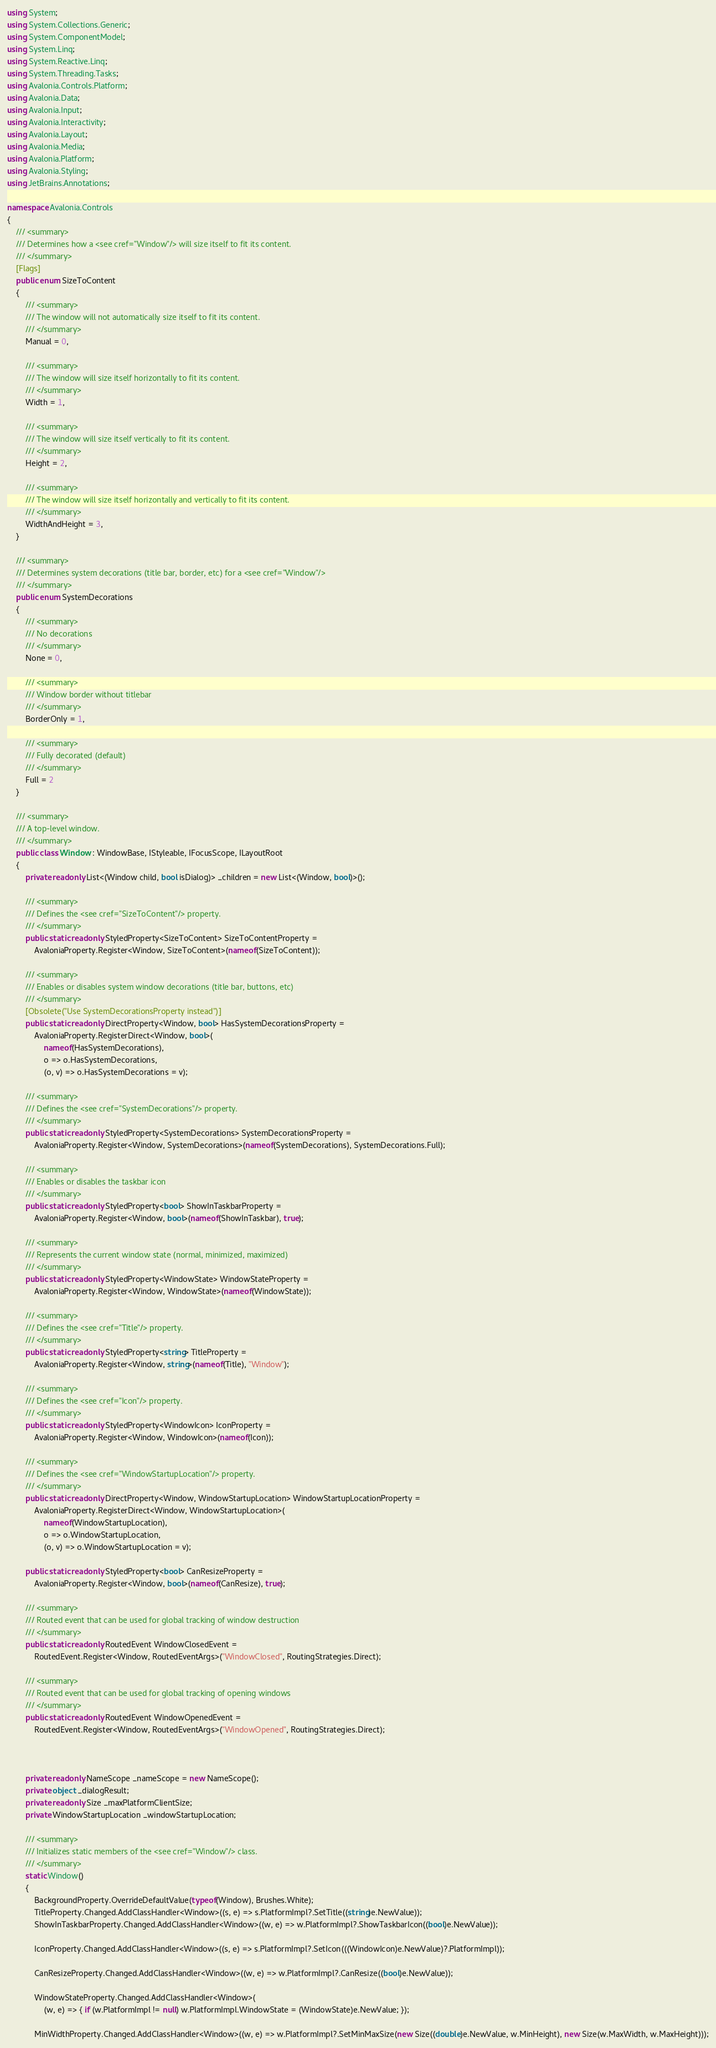<code> <loc_0><loc_0><loc_500><loc_500><_C#_>using System;
using System.Collections.Generic;
using System.ComponentModel;
using System.Linq;
using System.Reactive.Linq;
using System.Threading.Tasks;
using Avalonia.Controls.Platform;
using Avalonia.Data;
using Avalonia.Input;
using Avalonia.Interactivity;
using Avalonia.Layout;
using Avalonia.Media;
using Avalonia.Platform;
using Avalonia.Styling;
using JetBrains.Annotations;

namespace Avalonia.Controls
{
    /// <summary>
    /// Determines how a <see cref="Window"/> will size itself to fit its content.
    /// </summary>
    [Flags]
    public enum SizeToContent
    {
        /// <summary>
        /// The window will not automatically size itself to fit its content.
        /// </summary>
        Manual = 0,

        /// <summary>
        /// The window will size itself horizontally to fit its content.
        /// </summary>
        Width = 1,

        /// <summary>
        /// The window will size itself vertically to fit its content.
        /// </summary>
        Height = 2,

        /// <summary>
        /// The window will size itself horizontally and vertically to fit its content.
        /// </summary>
        WidthAndHeight = 3,
    }

    /// <summary>
    /// Determines system decorations (title bar, border, etc) for a <see cref="Window"/>
    /// </summary>
    public enum SystemDecorations
    {
        /// <summary>
        /// No decorations
        /// </summary>
        None = 0,

        /// <summary>
        /// Window border without titlebar
        /// </summary>
        BorderOnly = 1,

        /// <summary>
        /// Fully decorated (default)
        /// </summary>
        Full = 2
    }

    /// <summary>
    /// A top-level window.
    /// </summary>
    public class Window : WindowBase, IStyleable, IFocusScope, ILayoutRoot
    {
        private readonly List<(Window child, bool isDialog)> _children = new List<(Window, bool)>();

        /// <summary>
        /// Defines the <see cref="SizeToContent"/> property.
        /// </summary>
        public static readonly StyledProperty<SizeToContent> SizeToContentProperty =
            AvaloniaProperty.Register<Window, SizeToContent>(nameof(SizeToContent));

        /// <summary>
        /// Enables or disables system window decorations (title bar, buttons, etc)
        /// </summary>
        [Obsolete("Use SystemDecorationsProperty instead")]
        public static readonly DirectProperty<Window, bool> HasSystemDecorationsProperty =
            AvaloniaProperty.RegisterDirect<Window, bool>(
                nameof(HasSystemDecorations),
                o => o.HasSystemDecorations,
                (o, v) => o.HasSystemDecorations = v);

        /// <summary>
        /// Defines the <see cref="SystemDecorations"/> property.
        /// </summary>
        public static readonly StyledProperty<SystemDecorations> SystemDecorationsProperty =
            AvaloniaProperty.Register<Window, SystemDecorations>(nameof(SystemDecorations), SystemDecorations.Full);

        /// <summary>
        /// Enables or disables the taskbar icon
        /// </summary>
        public static readonly StyledProperty<bool> ShowInTaskbarProperty =
            AvaloniaProperty.Register<Window, bool>(nameof(ShowInTaskbar), true);

        /// <summary>
        /// Represents the current window state (normal, minimized, maximized)
        /// </summary>
        public static readonly StyledProperty<WindowState> WindowStateProperty =
            AvaloniaProperty.Register<Window, WindowState>(nameof(WindowState));

        /// <summary>
        /// Defines the <see cref="Title"/> property.
        /// </summary>
        public static readonly StyledProperty<string> TitleProperty =
            AvaloniaProperty.Register<Window, string>(nameof(Title), "Window");

        /// <summary>
        /// Defines the <see cref="Icon"/> property.
        /// </summary>
        public static readonly StyledProperty<WindowIcon> IconProperty =
            AvaloniaProperty.Register<Window, WindowIcon>(nameof(Icon));

        /// <summary>
        /// Defines the <see cref="WindowStartupLocation"/> property.
        /// </summary>
        public static readonly DirectProperty<Window, WindowStartupLocation> WindowStartupLocationProperty =
            AvaloniaProperty.RegisterDirect<Window, WindowStartupLocation>(
                nameof(WindowStartupLocation),
                o => o.WindowStartupLocation,
                (o, v) => o.WindowStartupLocation = v);

        public static readonly StyledProperty<bool> CanResizeProperty =
            AvaloniaProperty.Register<Window, bool>(nameof(CanResize), true);

        /// <summary>
        /// Routed event that can be used for global tracking of window destruction
        /// </summary>
        public static readonly RoutedEvent WindowClosedEvent =
            RoutedEvent.Register<Window, RoutedEventArgs>("WindowClosed", RoutingStrategies.Direct);

        /// <summary>
        /// Routed event that can be used for global tracking of opening windows
        /// </summary>
        public static readonly RoutedEvent WindowOpenedEvent =
            RoutedEvent.Register<Window, RoutedEventArgs>("WindowOpened", RoutingStrategies.Direct);



        private readonly NameScope _nameScope = new NameScope();
        private object _dialogResult;
        private readonly Size _maxPlatformClientSize;
        private WindowStartupLocation _windowStartupLocation;

        /// <summary>
        /// Initializes static members of the <see cref="Window"/> class.
        /// </summary>
        static Window()
        {
            BackgroundProperty.OverrideDefaultValue(typeof(Window), Brushes.White);
            TitleProperty.Changed.AddClassHandler<Window>((s, e) => s.PlatformImpl?.SetTitle((string)e.NewValue));
            ShowInTaskbarProperty.Changed.AddClassHandler<Window>((w, e) => w.PlatformImpl?.ShowTaskbarIcon((bool)e.NewValue));

            IconProperty.Changed.AddClassHandler<Window>((s, e) => s.PlatformImpl?.SetIcon(((WindowIcon)e.NewValue)?.PlatformImpl));

            CanResizeProperty.Changed.AddClassHandler<Window>((w, e) => w.PlatformImpl?.CanResize((bool)e.NewValue));

            WindowStateProperty.Changed.AddClassHandler<Window>(
                (w, e) => { if (w.PlatformImpl != null) w.PlatformImpl.WindowState = (WindowState)e.NewValue; });

            MinWidthProperty.Changed.AddClassHandler<Window>((w, e) => w.PlatformImpl?.SetMinMaxSize(new Size((double)e.NewValue, w.MinHeight), new Size(w.MaxWidth, w.MaxHeight)));</code> 